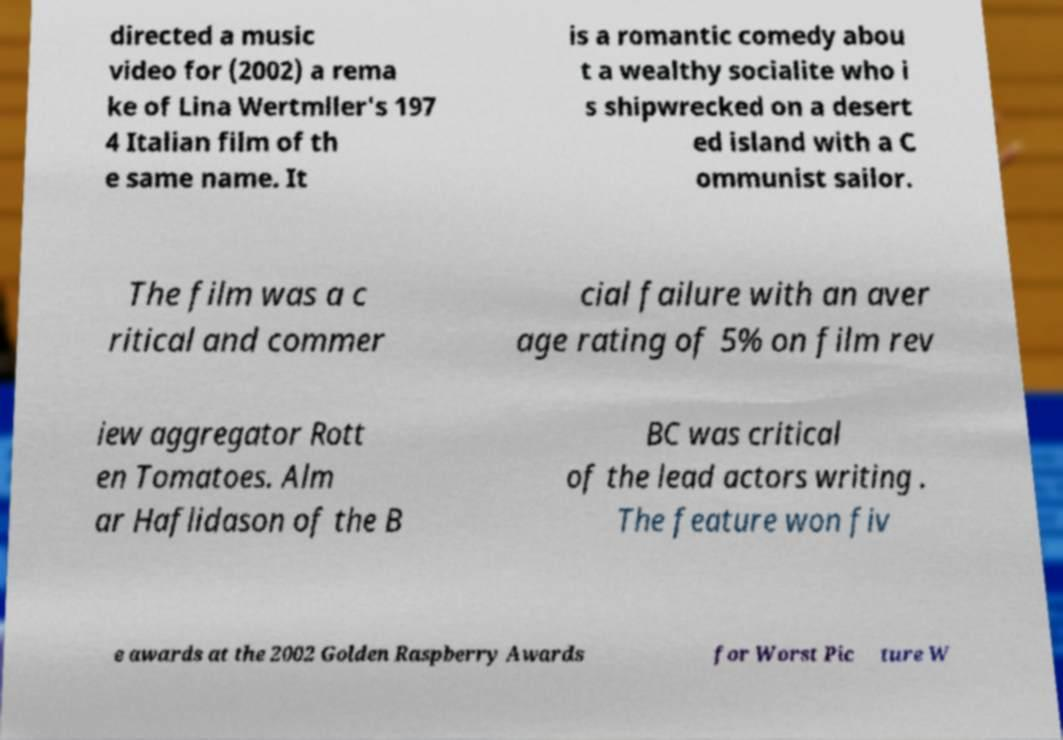Could you assist in decoding the text presented in this image and type it out clearly? directed a music video for (2002) a rema ke of Lina Wertmller's 197 4 Italian film of th e same name. It is a romantic comedy abou t a wealthy socialite who i s shipwrecked on a desert ed island with a C ommunist sailor. The film was a c ritical and commer cial failure with an aver age rating of 5% on film rev iew aggregator Rott en Tomatoes. Alm ar Haflidason of the B BC was critical of the lead actors writing . The feature won fiv e awards at the 2002 Golden Raspberry Awards for Worst Pic ture W 